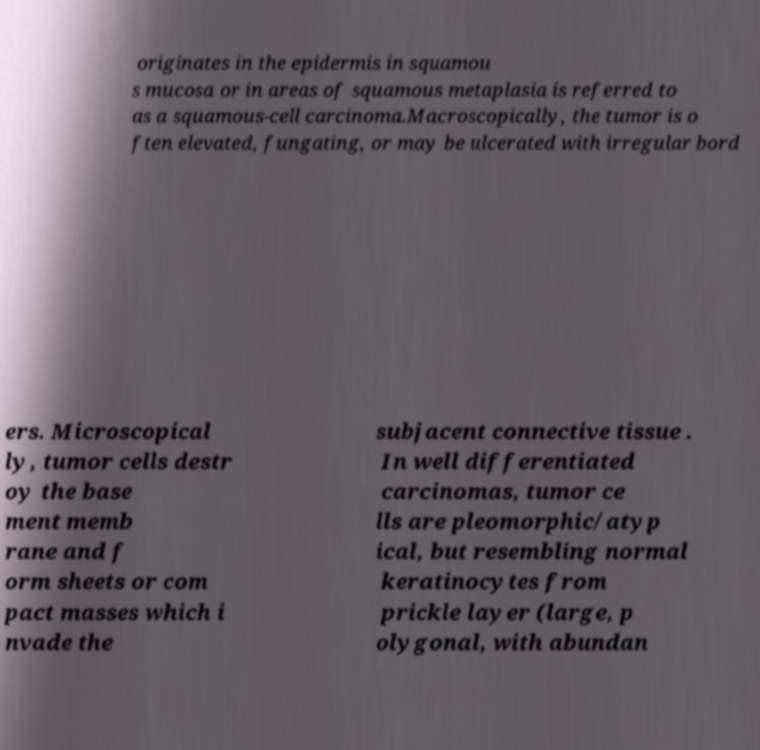Please identify and transcribe the text found in this image. originates in the epidermis in squamou s mucosa or in areas of squamous metaplasia is referred to as a squamous-cell carcinoma.Macroscopically, the tumor is o ften elevated, fungating, or may be ulcerated with irregular bord ers. Microscopical ly, tumor cells destr oy the base ment memb rane and f orm sheets or com pact masses which i nvade the subjacent connective tissue . In well differentiated carcinomas, tumor ce lls are pleomorphic/atyp ical, but resembling normal keratinocytes from prickle layer (large, p olygonal, with abundan 